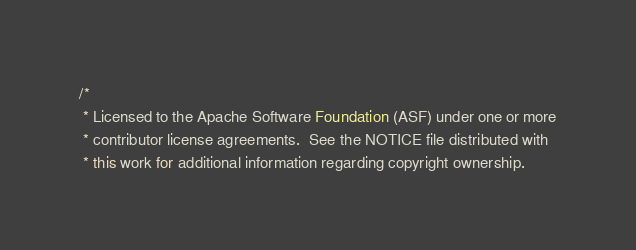Convert code to text. <code><loc_0><loc_0><loc_500><loc_500><_Java_>/*
 * Licensed to the Apache Software Foundation (ASF) under one or more
 * contributor license agreements.  See the NOTICE file distributed with
 * this work for additional information regarding copyright ownership.</code> 